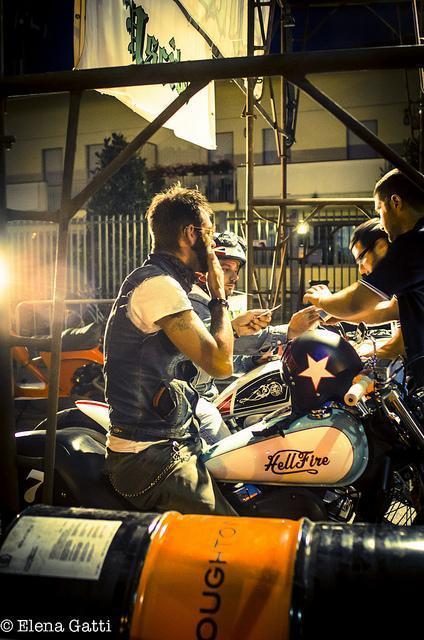How many people are there?
Give a very brief answer. 2. How many motorcycles are there?
Give a very brief answer. 3. 